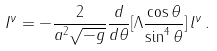Convert formula to latex. <formula><loc_0><loc_0><loc_500><loc_500>I ^ { \nu } = - \frac { 2 } { a ^ { 2 } \sqrt { - g } } \frac { d } { d \theta } [ \Lambda \frac { \cos { \theta } } { \sin ^ { 4 } { \theta } } ] \, l ^ { \nu } \, .</formula> 